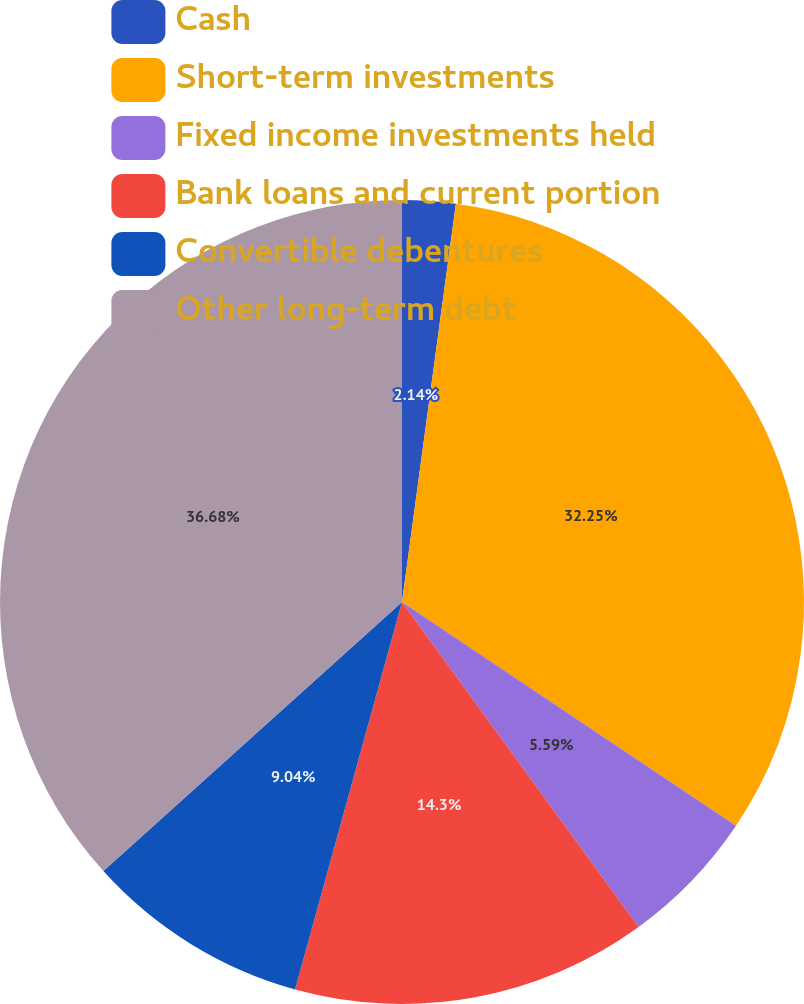Convert chart. <chart><loc_0><loc_0><loc_500><loc_500><pie_chart><fcel>Cash<fcel>Short-term investments<fcel>Fixed income investments held<fcel>Bank loans and current portion<fcel>Convertible debentures<fcel>Other long-term debt<nl><fcel>2.14%<fcel>32.25%<fcel>5.59%<fcel>14.3%<fcel>9.04%<fcel>36.67%<nl></chart> 